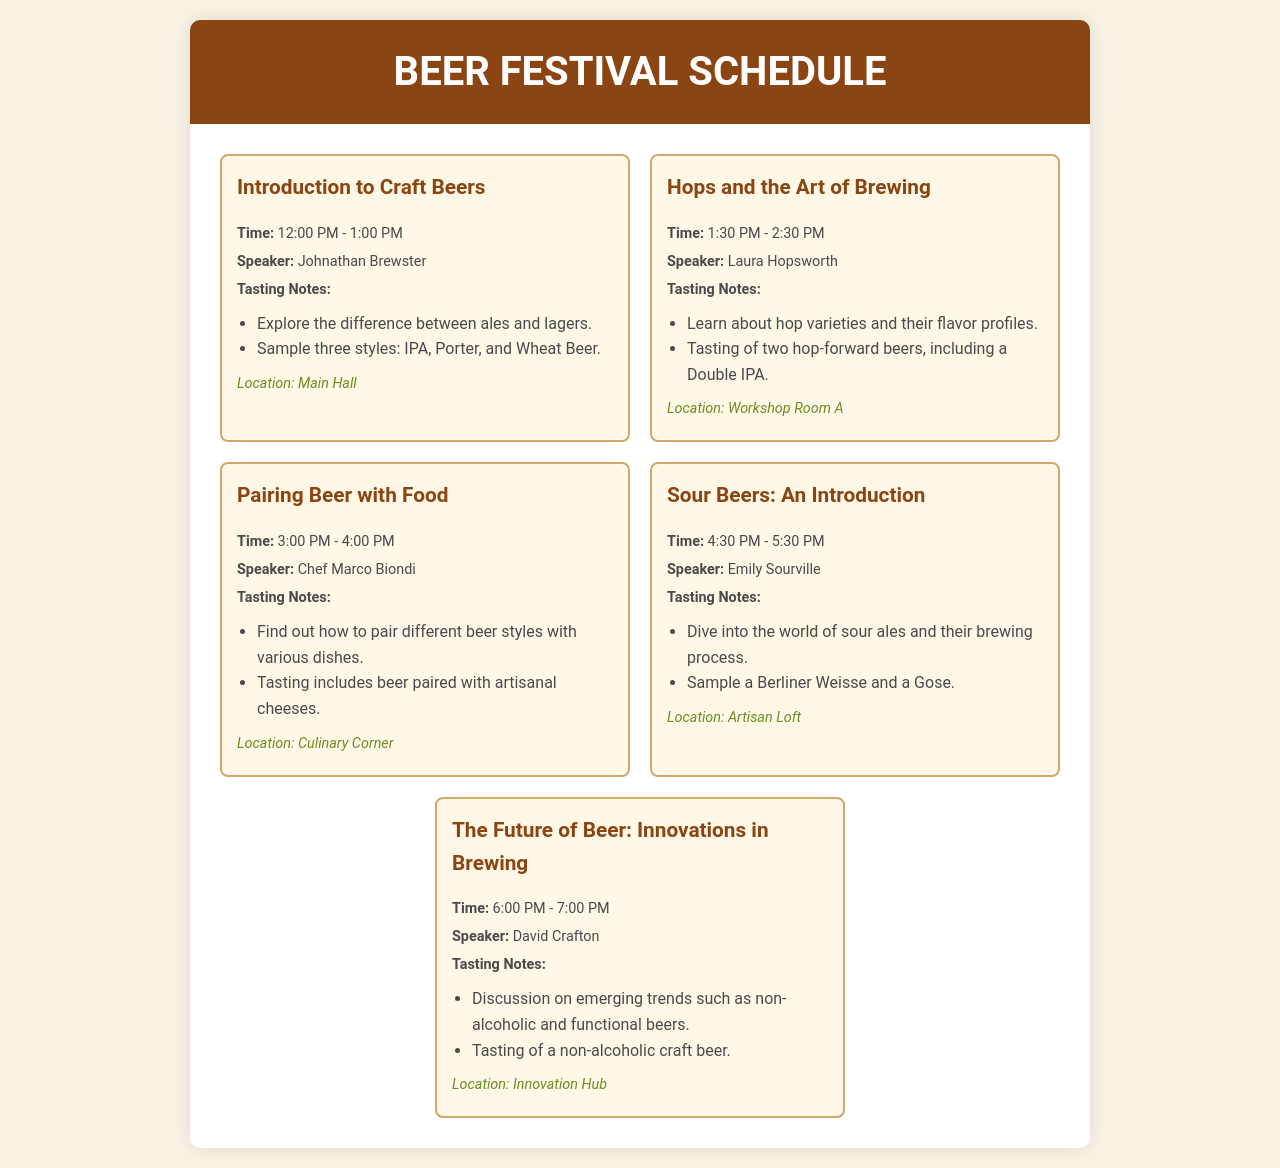What is the first session of the day? The first session is titled "Introduction to Craft Beers."
Answer: Introduction to Craft Beers Who is the speaker for the "Hops and the Art of Brewing" session? The speaker for this session is Laura Hopsworth.
Answer: Laura Hopsworth What time does the "Pairing Beer with Food" session start? This session starts at 3:00 PM.
Answer: 3:00 PM How many styles of beer are sampled in the "Introduction to Craft Beers" session? Three styles of beer are sampled in this session.
Answer: Three styles Where will the "Sour Beers: An Introduction" session take place? This session will be held in the Artisan Loft.
Answer: Artisan Loft Which session discusses innovations in brewing? The session titled "The Future of Beer: Innovations in Brewing" discusses this topic.
Answer: The Future of Beer: Innovations in Brewing What type of beer is included in the tasting for the last session? The tasting includes a non-alcoholic craft beer.
Answer: Non-alcoholic craft beer What is the location of the first session? The first session is located in the Main Hall.
Answer: Main Hall What is the total number of sessions listed in the schedule? There are five sessions listed in the schedule.
Answer: Five sessions 